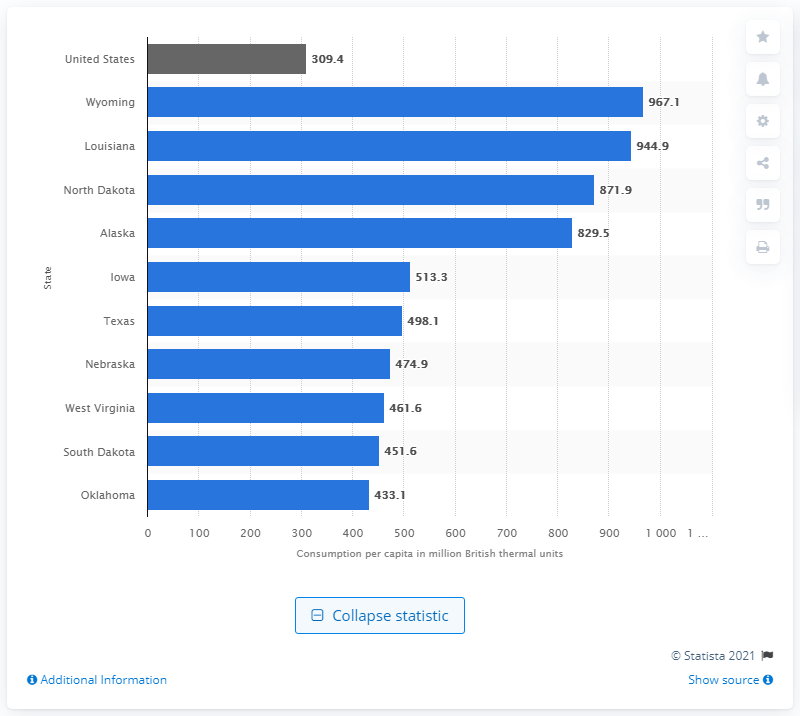Specify some key components in this picture. North Dakota consumed 871.9 million British thermal units of energy in 2018. North Dakota, a state located in the United States, is situated in the northern region of the country. 